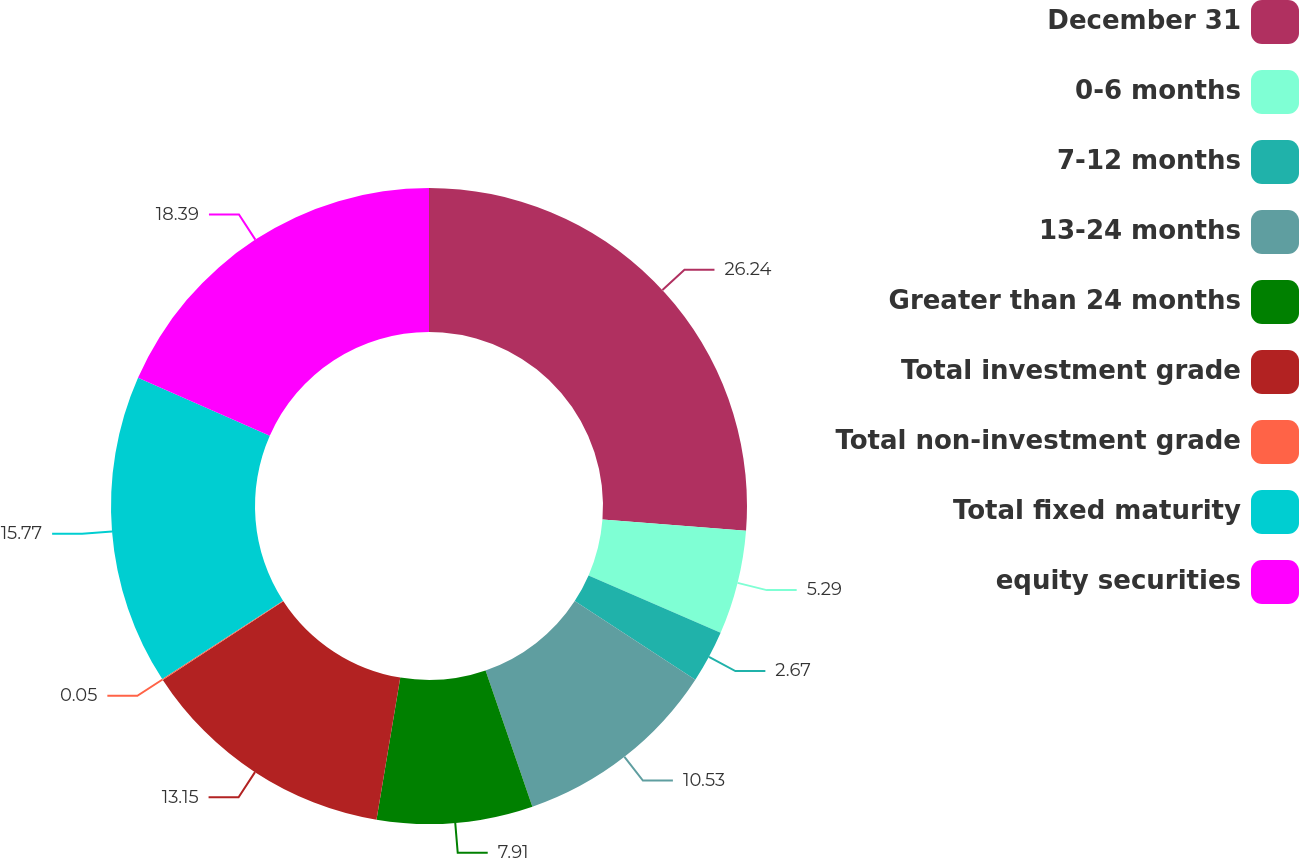Convert chart to OTSL. <chart><loc_0><loc_0><loc_500><loc_500><pie_chart><fcel>December 31<fcel>0-6 months<fcel>7-12 months<fcel>13-24 months<fcel>Greater than 24 months<fcel>Total investment grade<fcel>Total non-investment grade<fcel>Total fixed maturity<fcel>equity securities<nl><fcel>26.24%<fcel>5.29%<fcel>2.67%<fcel>10.53%<fcel>7.91%<fcel>13.15%<fcel>0.05%<fcel>15.77%<fcel>18.39%<nl></chart> 